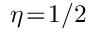Convert formula to latex. <formula><loc_0><loc_0><loc_500><loc_500>\eta \, = \, 1 / 2</formula> 